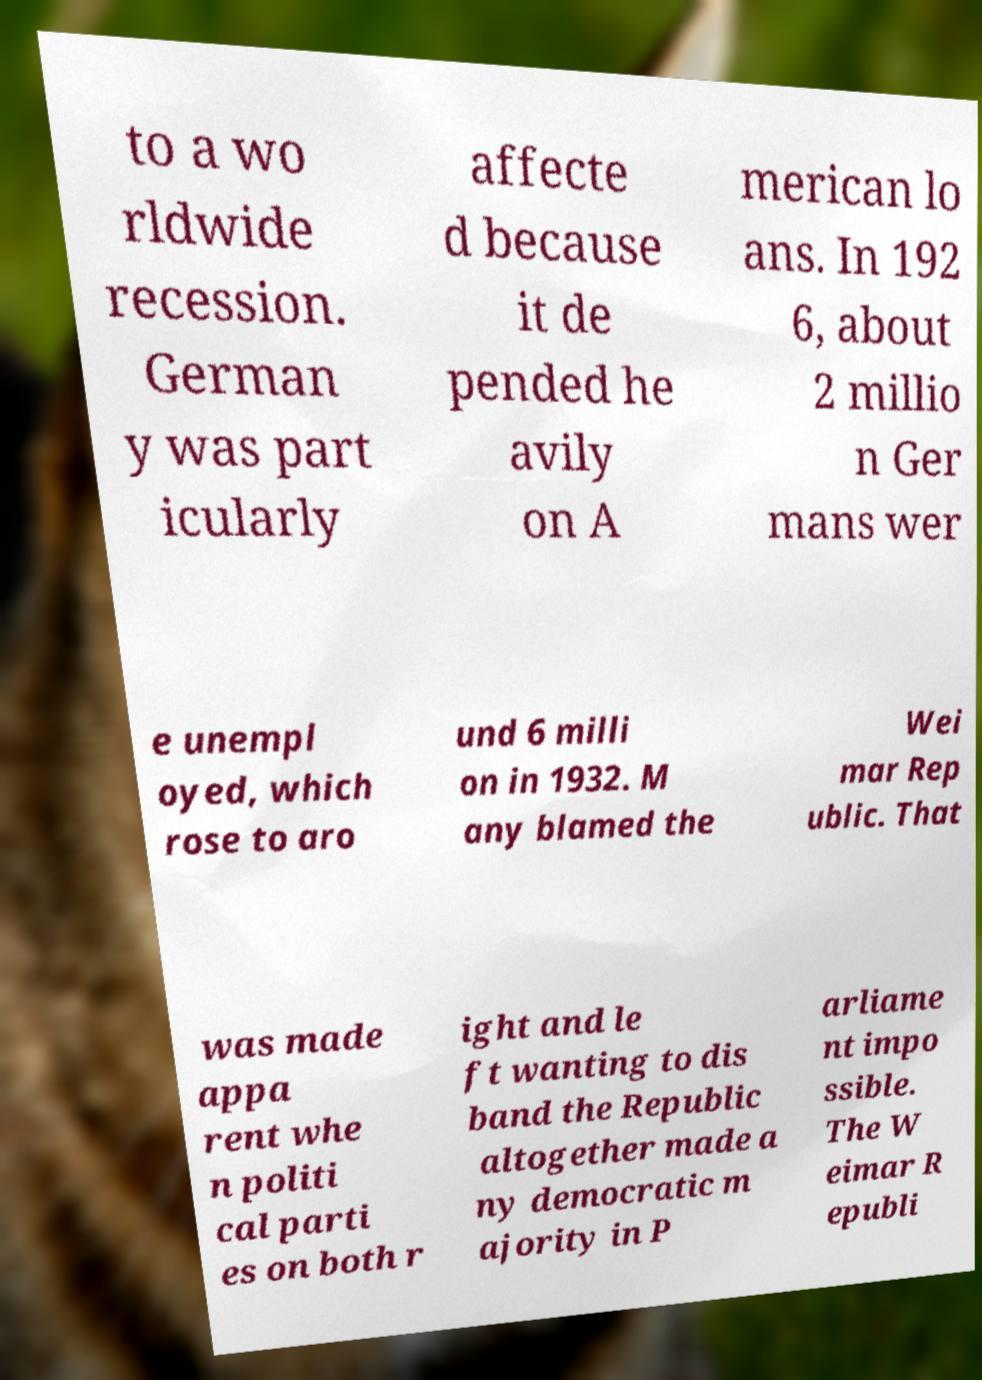Can you read and provide the text displayed in the image?This photo seems to have some interesting text. Can you extract and type it out for me? to a wo rldwide recession. German y was part icularly affecte d because it de pended he avily on A merican lo ans. In 192 6, about 2 millio n Ger mans wer e unempl oyed, which rose to aro und 6 milli on in 1932. M any blamed the Wei mar Rep ublic. That was made appa rent whe n politi cal parti es on both r ight and le ft wanting to dis band the Republic altogether made a ny democratic m ajority in P arliame nt impo ssible. The W eimar R epubli 